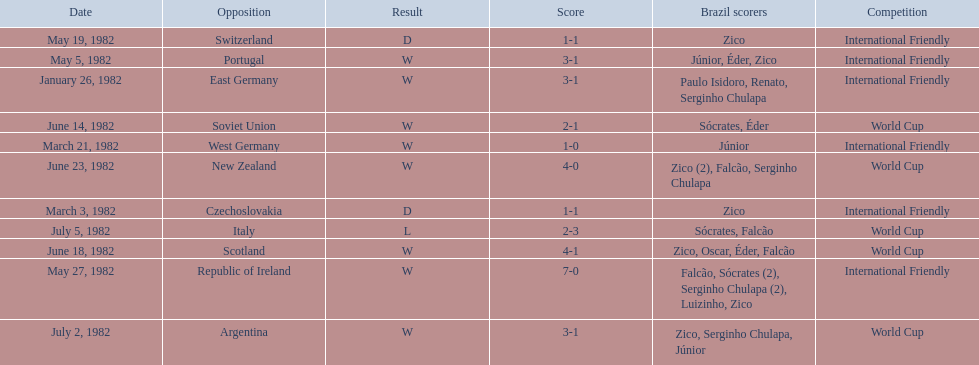How many games did zico end up scoring in during this season? 7. 